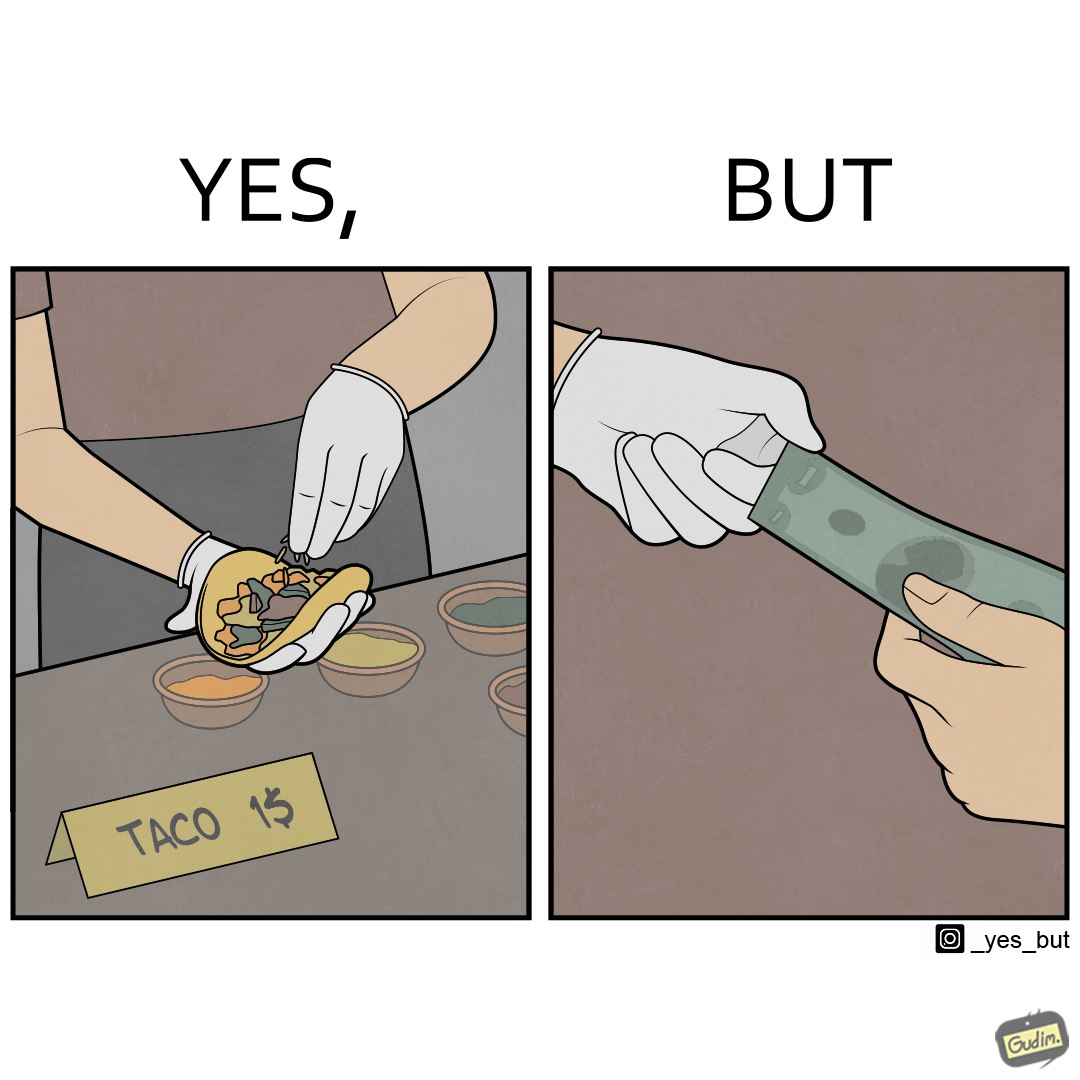Describe the satirical element in this image. The image is satirical because the intention of wearing a glove while preparing food is to not let any germs and dirt from our hands get into the food, people do other tasks like collecting money from the customer wearing the same gloves and thus making the gloves themselves dirty. 